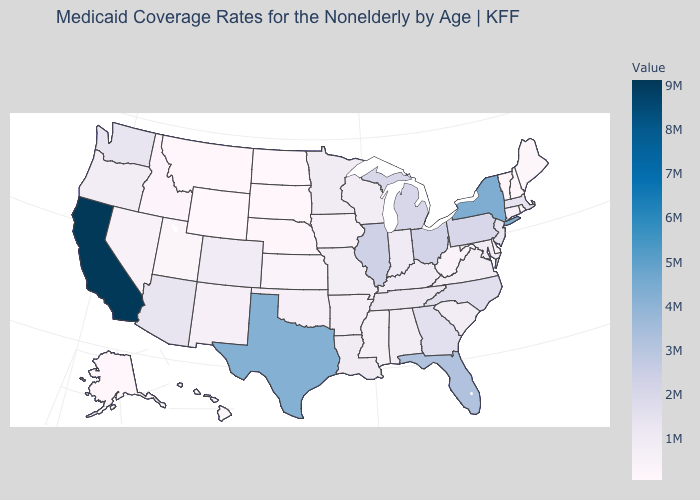Is the legend a continuous bar?
Short answer required. Yes. Is the legend a continuous bar?
Quick response, please. Yes. Does Wyoming have the lowest value in the USA?
Write a very short answer. Yes. Among the states that border Kentucky , which have the highest value?
Write a very short answer. Illinois. 